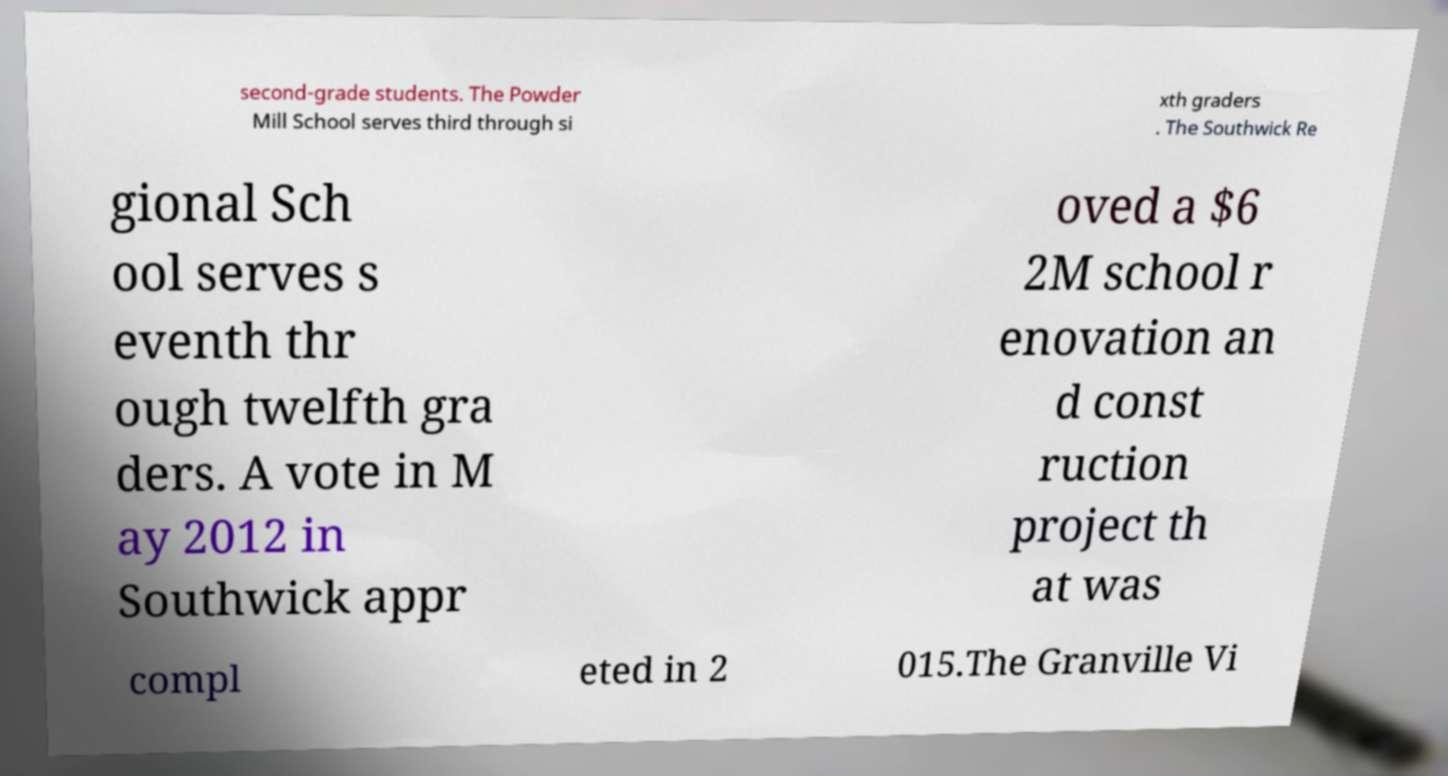Can you accurately transcribe the text from the provided image for me? second-grade students. The Powder Mill School serves third through si xth graders . The Southwick Re gional Sch ool serves s eventh thr ough twelfth gra ders. A vote in M ay 2012 in Southwick appr oved a $6 2M school r enovation an d const ruction project th at was compl eted in 2 015.The Granville Vi 